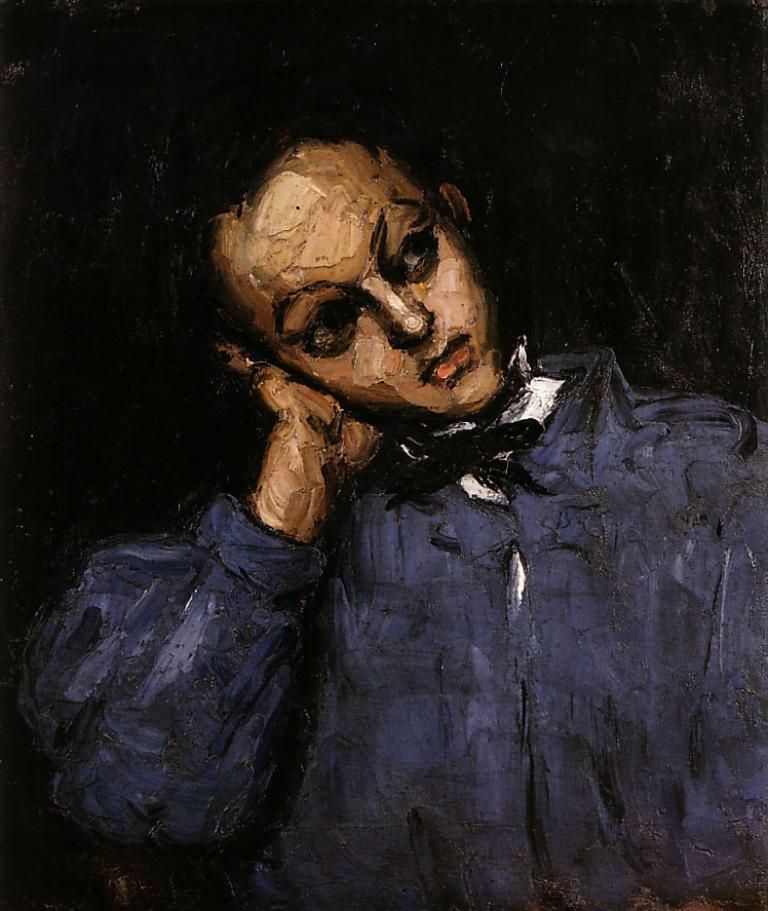What type of artwork is depicted in the image? The image is a painting. Can you describe the person in the painting? There is a person in the painting. What color is the shirt worn by the person in the painting? The person is wearing a blue shirt. What is the color of the background in the painting? The background of the painting is black in color. What holiday is being celebrated in the painting? There is no indication of a holiday being celebrated in the painting. What type of attraction is depicted in the painting? There is no attraction depicted in the painting; it features a person wearing a blue shirt against a black background. 